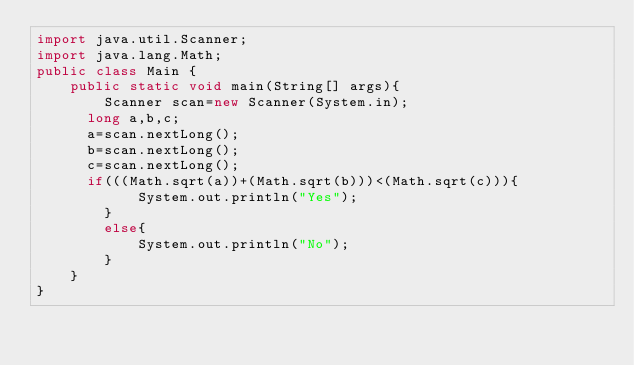Convert code to text. <code><loc_0><loc_0><loc_500><loc_500><_Java_>import java.util.Scanner;
import java.lang.Math;
public class Main {
    public static void main(String[] args){
        Scanner scan=new Scanner(System.in);
      long a,b,c;
      a=scan.nextLong();
      b=scan.nextLong();
      c=scan.nextLong();
      if(((Math.sqrt(a))+(Math.sqrt(b)))<(Math.sqrt(c))){
            System.out.println("Yes");
        }
        else{
            System.out.println("No");
        }
    }
}
</code> 